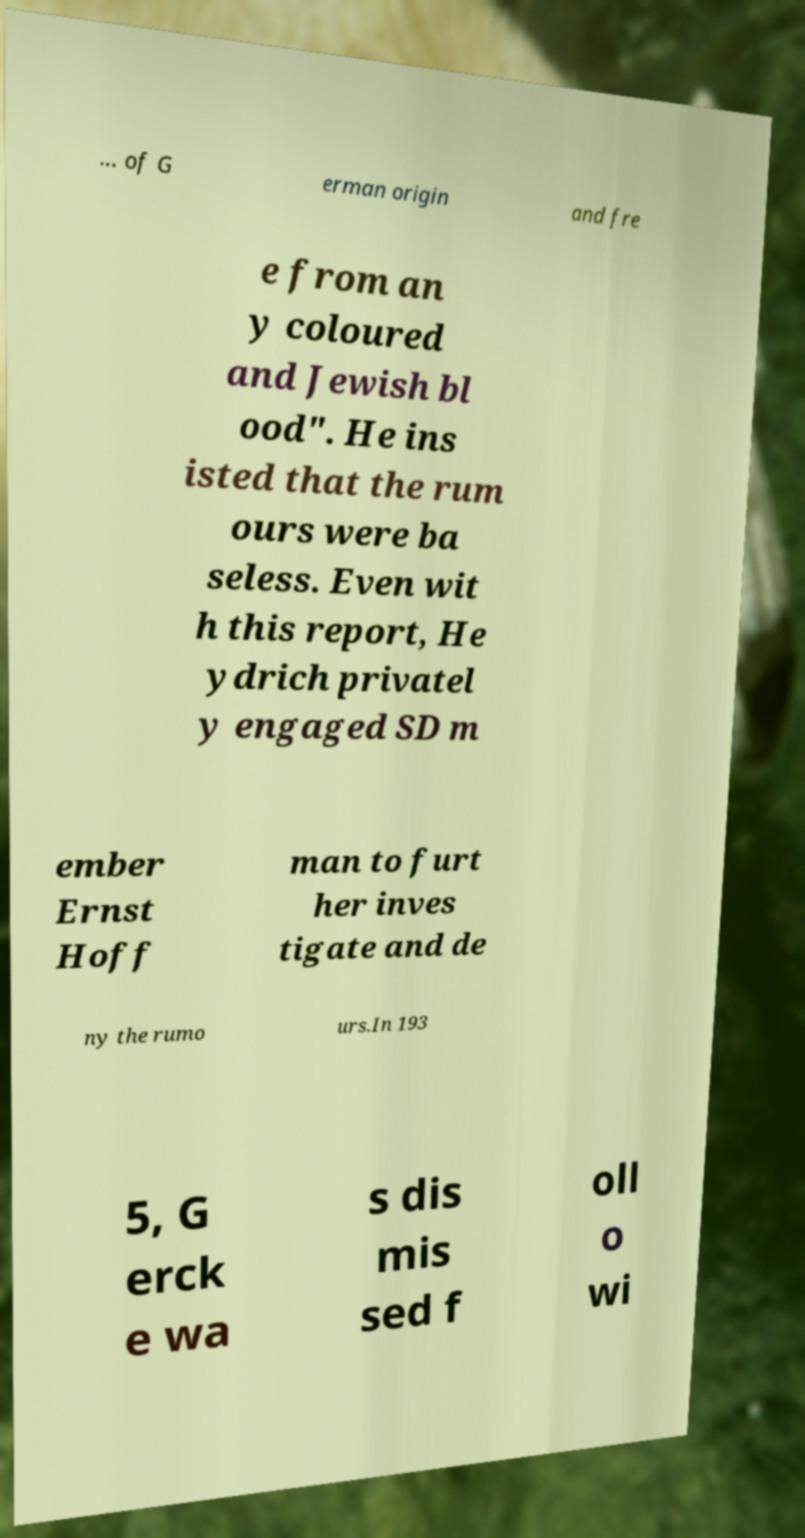Can you read and provide the text displayed in the image?This photo seems to have some interesting text. Can you extract and type it out for me? ... of G erman origin and fre e from an y coloured and Jewish bl ood". He ins isted that the rum ours were ba seless. Even wit h this report, He ydrich privatel y engaged SD m ember Ernst Hoff man to furt her inves tigate and de ny the rumo urs.In 193 5, G erck e wa s dis mis sed f oll o wi 